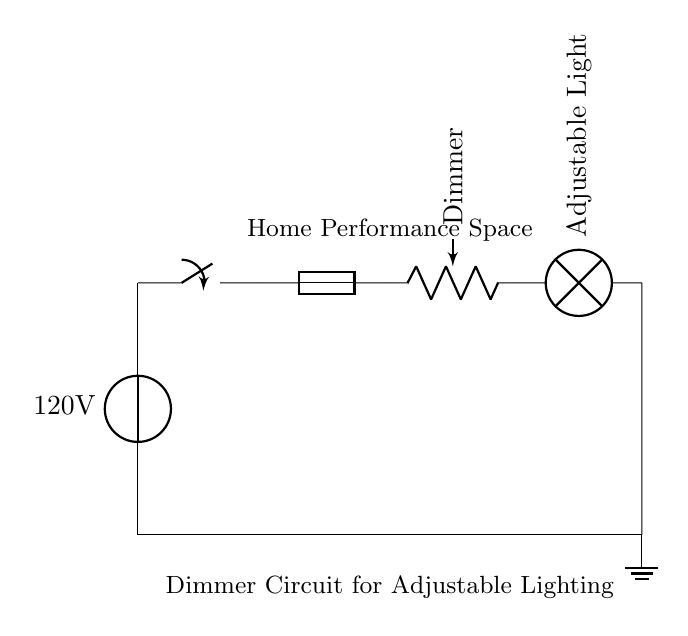What is the voltage of this circuit? The circuit diagram specifies a voltage source labeled as 120V at the starting point, indicating the potential difference supplied to the circuit.
Answer: 120 volts What type of component is the dimmer? The circuit shows a component labeled as a potentiometer, which is used here as a dimmer for controlling the light intensity.
Answer: Potentiometer How many lamps are present in this circuit? The diagram indicates there is one lamp component labeled as Adjustable Light, showing only one lamp connected to the circuit.
Answer: One What safety component is included in the circuit? The circuit includes a fuse component, which protects against overcurrent situations by breaking the circuit if the current exceeds a safe level.
Answer: Fuse How does the dimmer affect the light? The dimmer, represented as a potentiometer, can adjust the resistance in the circuit, thereby controlling the brightness of the light based on the resistance set.
Answer: Controls brightness What happens when the switch is turned off? When the switch is opened, the current flow to the light bulb is interrupted, effectively turning off the light. The circuit is broken, so no current can pass.
Answer: Light turns off 